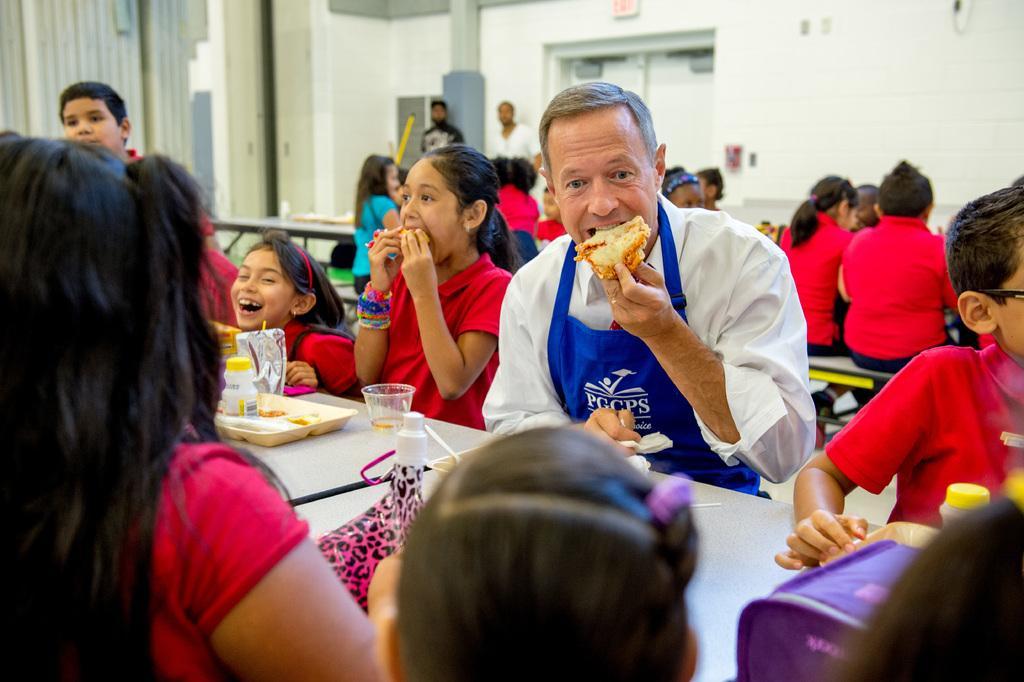How would you summarize this image in a sentence or two? In this picture there are many kids and eating on the table and there is a chef with a food item in one of his hand. In the background we observe an exit door. 